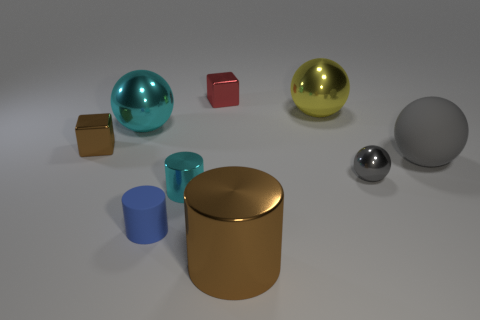Subtract all tiny cylinders. How many cylinders are left? 1 Subtract all gray balls. How many balls are left? 2 Subtract all cylinders. How many objects are left? 6 Subtract all green cylinders. How many red cubes are left? 1 Subtract all blue matte objects. Subtract all big brown rubber spheres. How many objects are left? 8 Add 5 red things. How many red things are left? 6 Add 8 tiny yellow cylinders. How many tiny yellow cylinders exist? 8 Add 1 tiny brown matte cubes. How many objects exist? 10 Subtract 0 purple spheres. How many objects are left? 9 Subtract 1 cylinders. How many cylinders are left? 2 